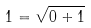<formula> <loc_0><loc_0><loc_500><loc_500>1 = \sqrt { 0 + 1 }</formula> 